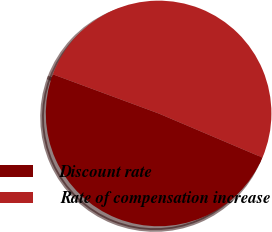<chart> <loc_0><loc_0><loc_500><loc_500><pie_chart><fcel>Discount rate<fcel>Rate of compensation increase<nl><fcel>49.24%<fcel>50.76%<nl></chart> 